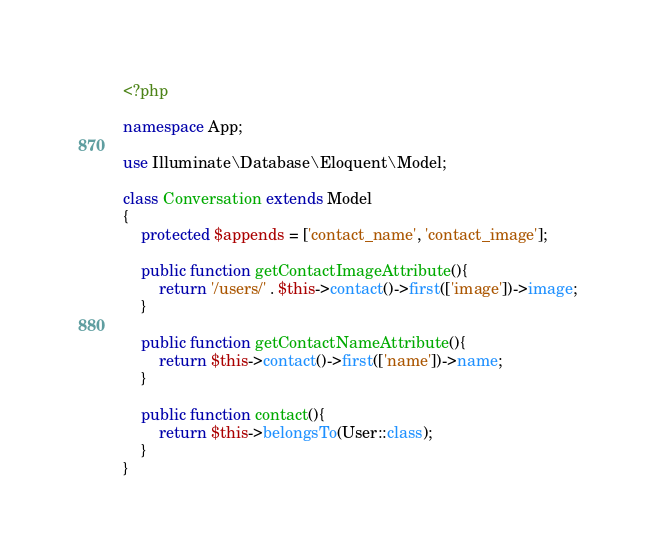Convert code to text. <code><loc_0><loc_0><loc_500><loc_500><_PHP_><?php

namespace App;

use Illuminate\Database\Eloquent\Model;

class Conversation extends Model
{
	protected $appends = ['contact_name', 'contact_image'];

	public function getContactImageAttribute(){
    	return '/users/' . $this->contact()->first(['image'])->image;
    }

    public function getContactNameAttribute(){
    	return $this->contact()->first(['name'])->name;
    }

    public function contact(){
    	return $this->belongsTo(User::class);
    }
}
</code> 